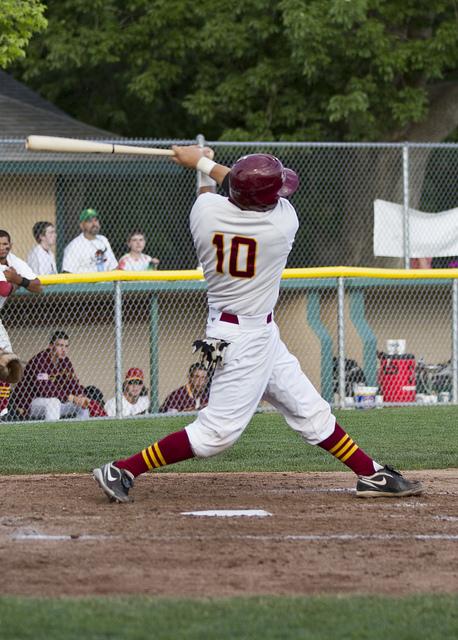What sport is it?
Give a very brief answer. Baseball. What number is this player?
Concise answer only. 10. What did the player just do?
Short answer required. Hit ball. 